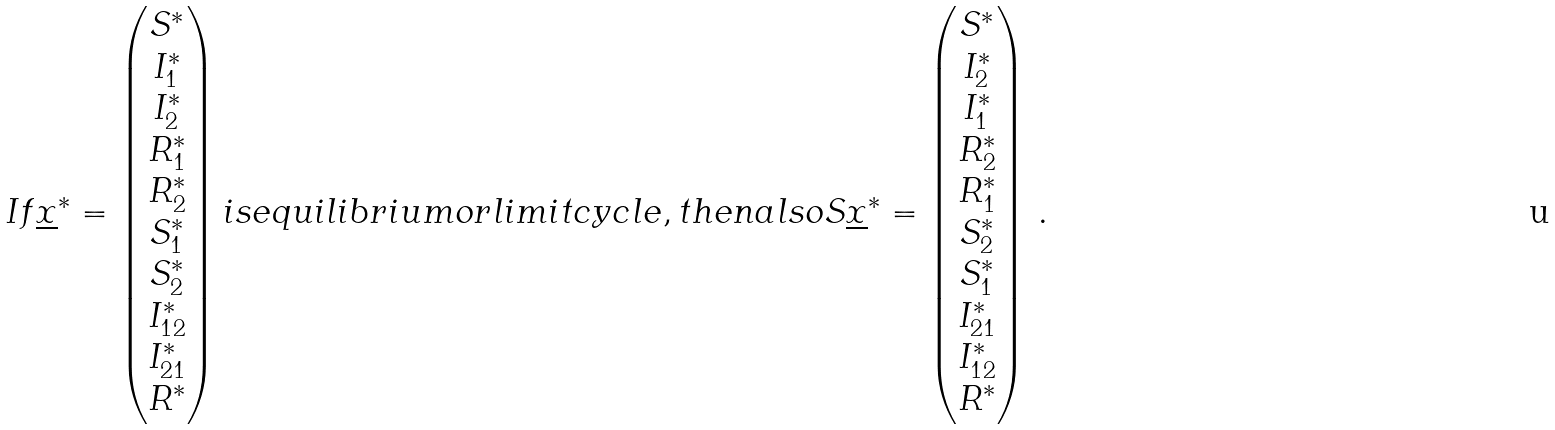<formula> <loc_0><loc_0><loc_500><loc_500>I f \underline { x } ^ { * } = \begin{pmatrix} S ^ { * } \\ I _ { 1 } ^ { * } \\ I _ { 2 } ^ { * } \\ R _ { 1 } ^ { * } \\ R _ { 2 } ^ { * } \\ S _ { 1 } ^ { * } \\ S _ { 2 } ^ { * } \\ I _ { 1 2 } ^ { * } \\ I _ { 2 1 } ^ { * } \\ R ^ { * } \end{pmatrix} i s e q u i l i b r i u m o r l i m i t c y c l e , t h e n a l s o S \underline { x } ^ { * } = \begin{pmatrix} S ^ { * } \\ I _ { 2 } ^ { * } \\ I _ { 1 } ^ { * } \\ R _ { 2 } ^ { * } \\ R _ { 1 } ^ { * } \\ S _ { 2 } ^ { * } \\ S _ { 1 } ^ { * } \\ I _ { 2 1 } ^ { * } \\ I _ { 1 2 } ^ { * } \\ R ^ { * } \end{pmatrix} \, .</formula> 